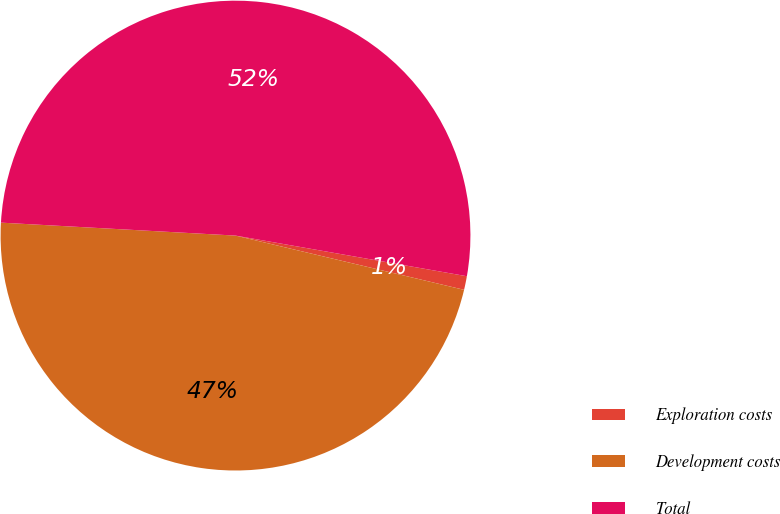Convert chart. <chart><loc_0><loc_0><loc_500><loc_500><pie_chart><fcel>Exploration costs<fcel>Development costs<fcel>Total<nl><fcel>0.94%<fcel>47.17%<fcel>51.89%<nl></chart> 